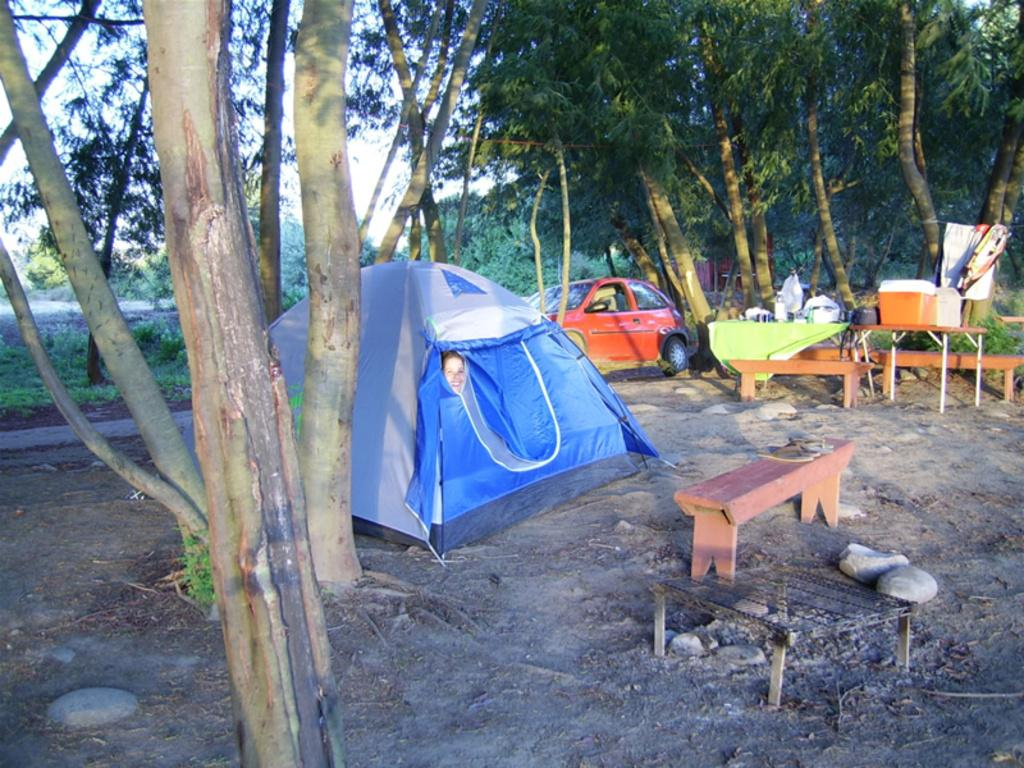What is the main structure in the middle of the image? There is a tent in the middle of the image. Who or what is inside the tent? A person is inside the tent. What can be seen in the background of the image? There are trees visible behind the tent. What vehicle is on the right side of the image? There is a car on the right side of the image. Are there any dinosaurs visible in the image? No, there are no dinosaurs present in the image. What class is the person inside the tent attending? There is no information about a class or any educational activity in the image. 